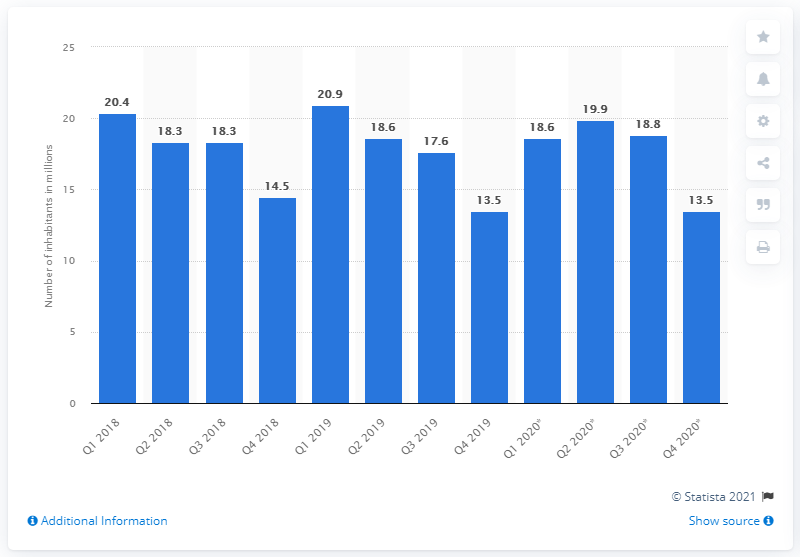List a handful of essential elements in this visual. In the fourth quarter of 2020, it was estimated that 13.5 million people in Russia lived under the poverty line. 